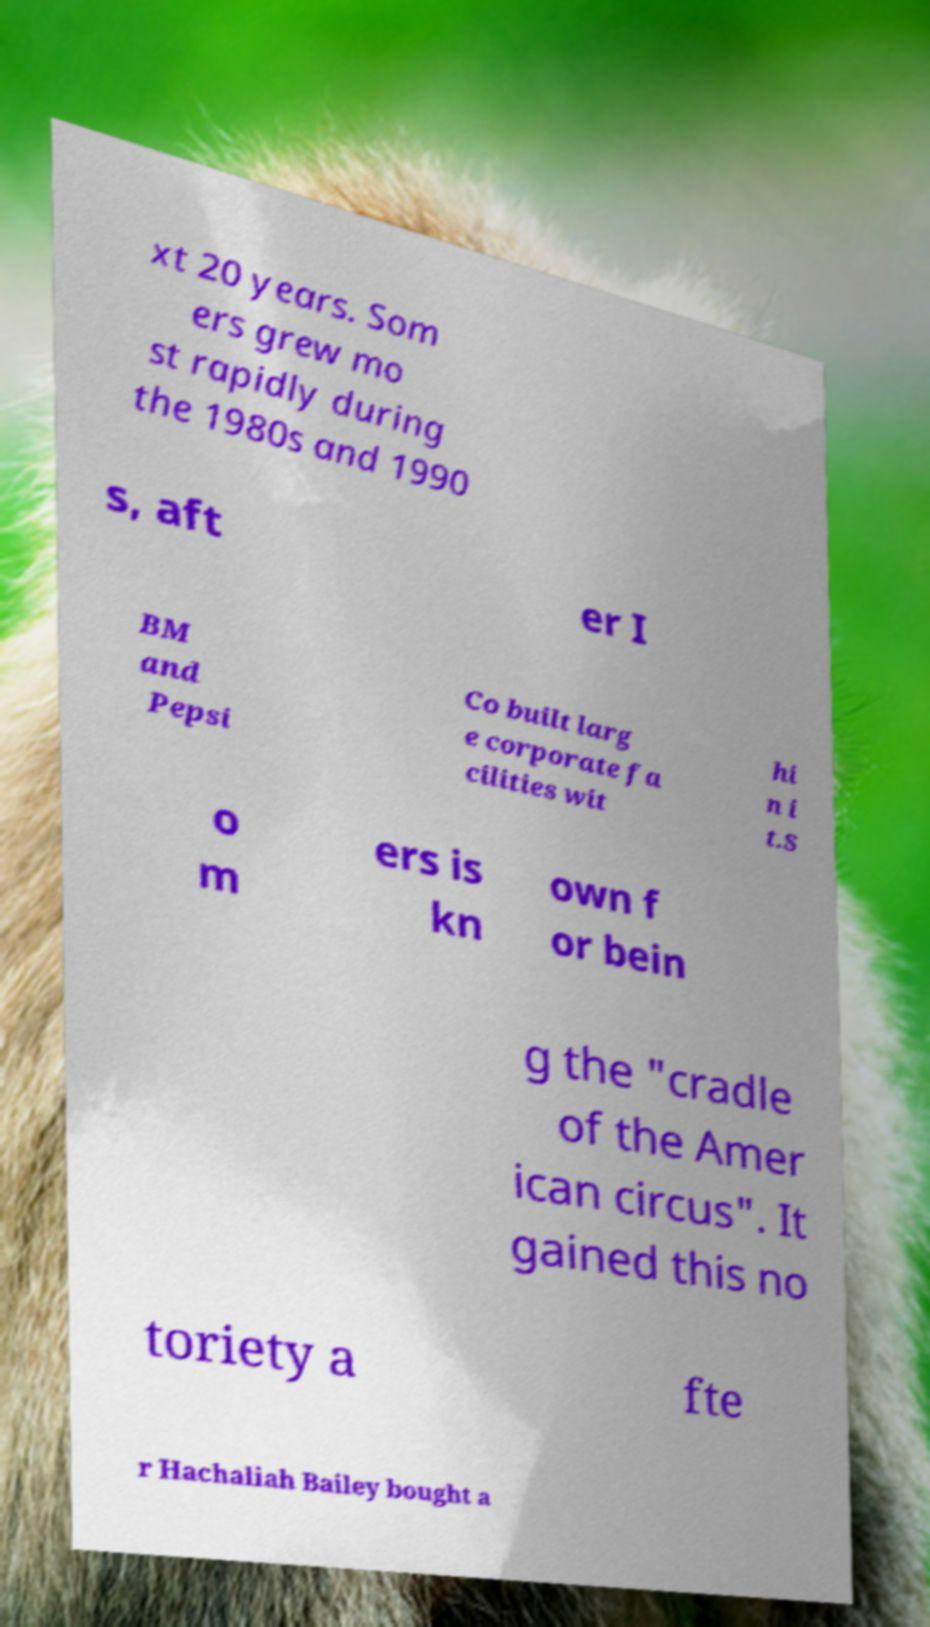For documentation purposes, I need the text within this image transcribed. Could you provide that? xt 20 years. Som ers grew mo st rapidly during the 1980s and 1990 s, aft er I BM and Pepsi Co built larg e corporate fa cilities wit hi n i t.S o m ers is kn own f or bein g the "cradle of the Amer ican circus". It gained this no toriety a fte r Hachaliah Bailey bought a 